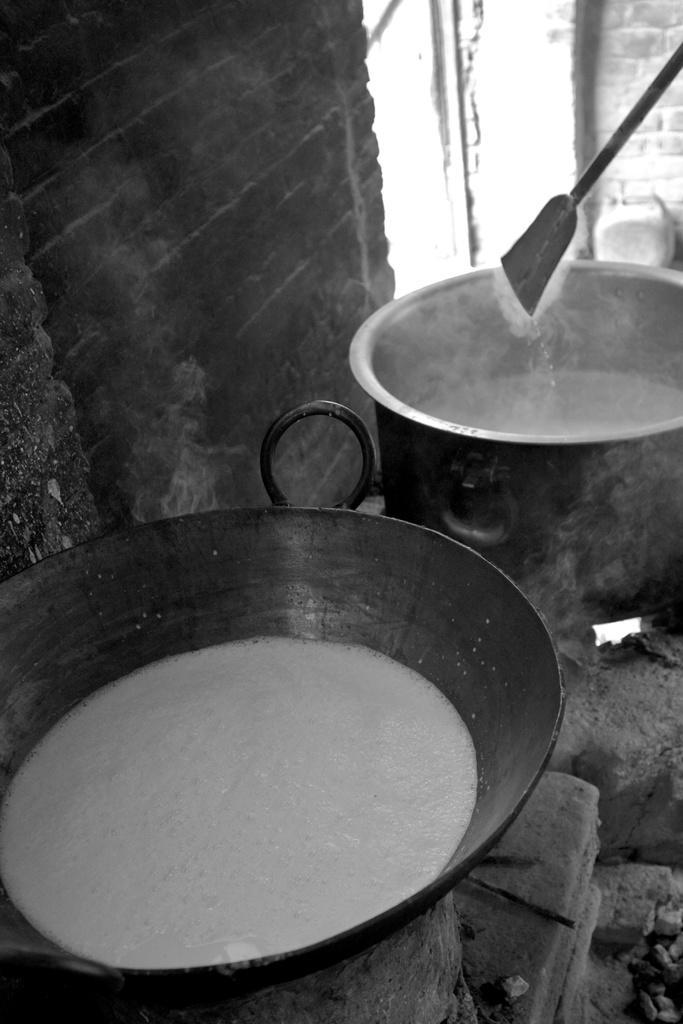Please provide a concise description of this image. In the image there is some food is being cooked in two vessels,they are cooked on brick stove and behind the vessel there is a brick wall. 